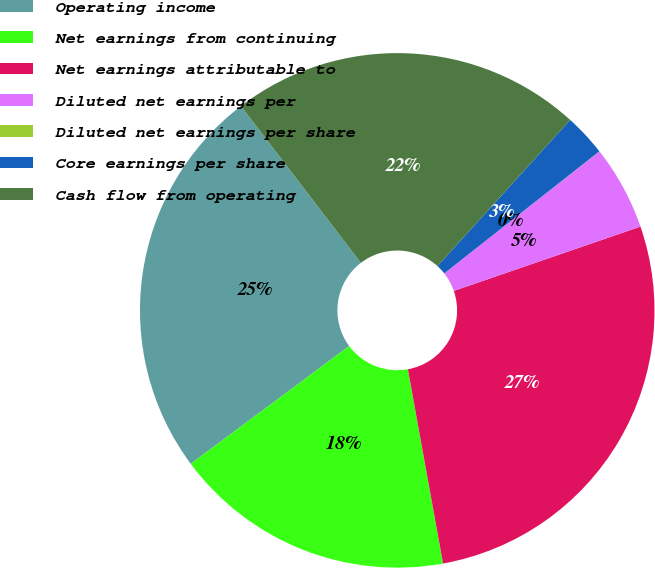<chart> <loc_0><loc_0><loc_500><loc_500><pie_chart><fcel>Operating income<fcel>Net earnings from continuing<fcel>Net earnings attributable to<fcel>Diluted net earnings per<fcel>Diluted net earnings per share<fcel>Core earnings per share<fcel>Cash flow from operating<nl><fcel>24.78%<fcel>17.68%<fcel>27.43%<fcel>5.32%<fcel>0.01%<fcel>2.66%<fcel>22.12%<nl></chart> 